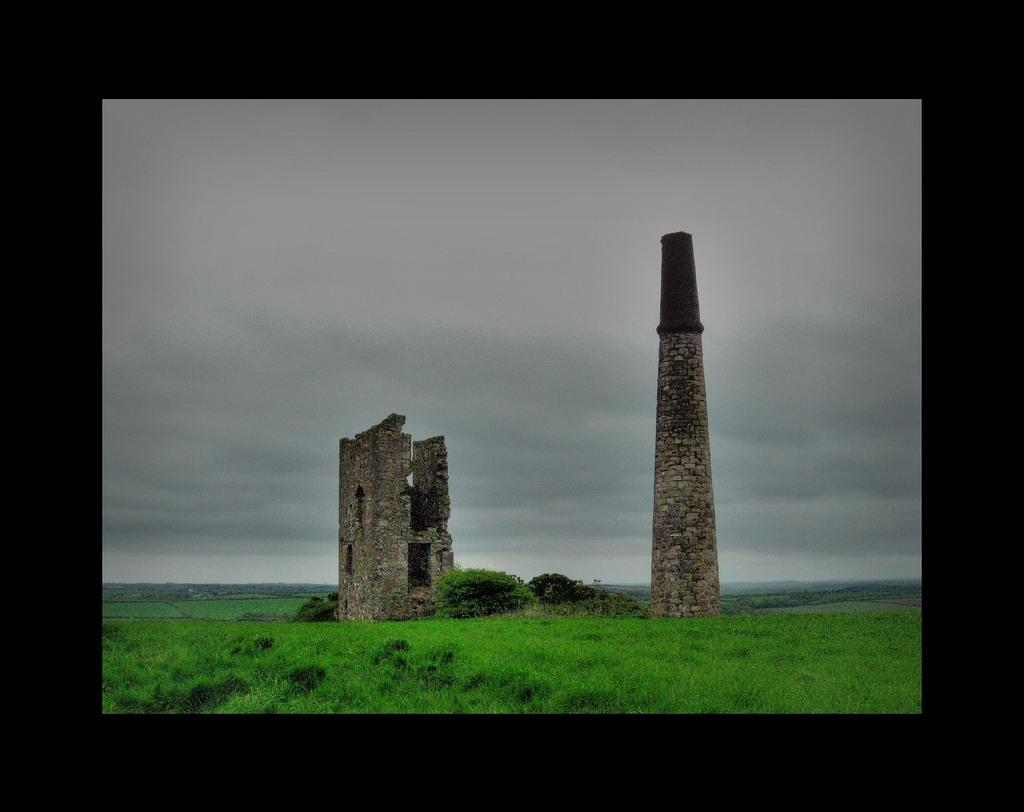What is the main structure visible in the image? There is a tower with bricks in the image. What is the condition of the tower's surroundings? The tower appears to be standing among the ruins of a destroyed building. What type of terrain is the destroyed building situated on? The destroyed building is on the grass. What can be seen in the background of the image? The sky is visible in the background of the image. Who is the achiever responsible for creating the tower in the image? The image does not provide information about who built the tower or any achievements related to it. 